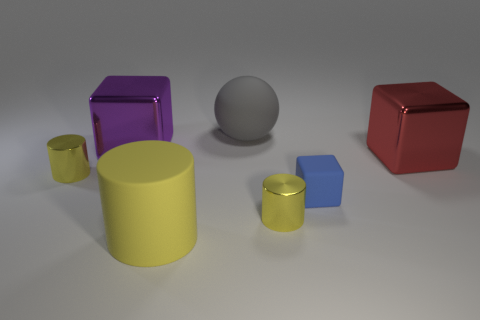Can you describe the shapes and colors of the objects in the image? Certainly! The image features a collection of six objects with varying shapes and colors. On the left, we have a small yellow cylinder and a larger one of the same color. There's a bright purple cube, a neutral gray sphere, a small blue cube, and on the far right, a shiny red cube. The objects are arranged on a flat surface with a light source creating soft shadows beneath them. 